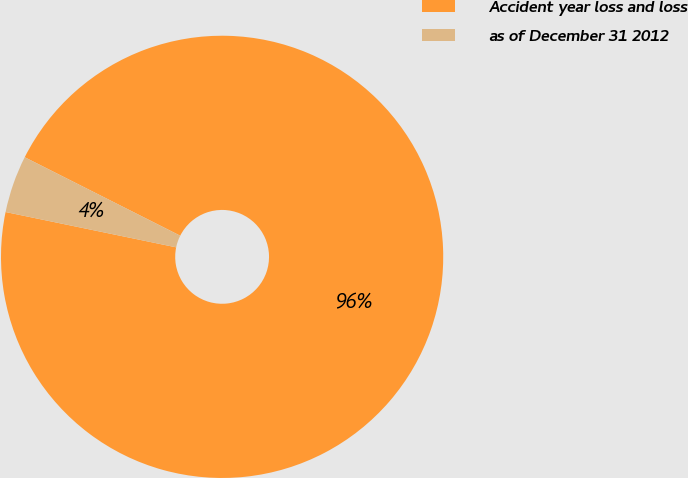Convert chart. <chart><loc_0><loc_0><loc_500><loc_500><pie_chart><fcel>Accident year loss and loss<fcel>as of December 31 2012<nl><fcel>95.81%<fcel>4.19%<nl></chart> 